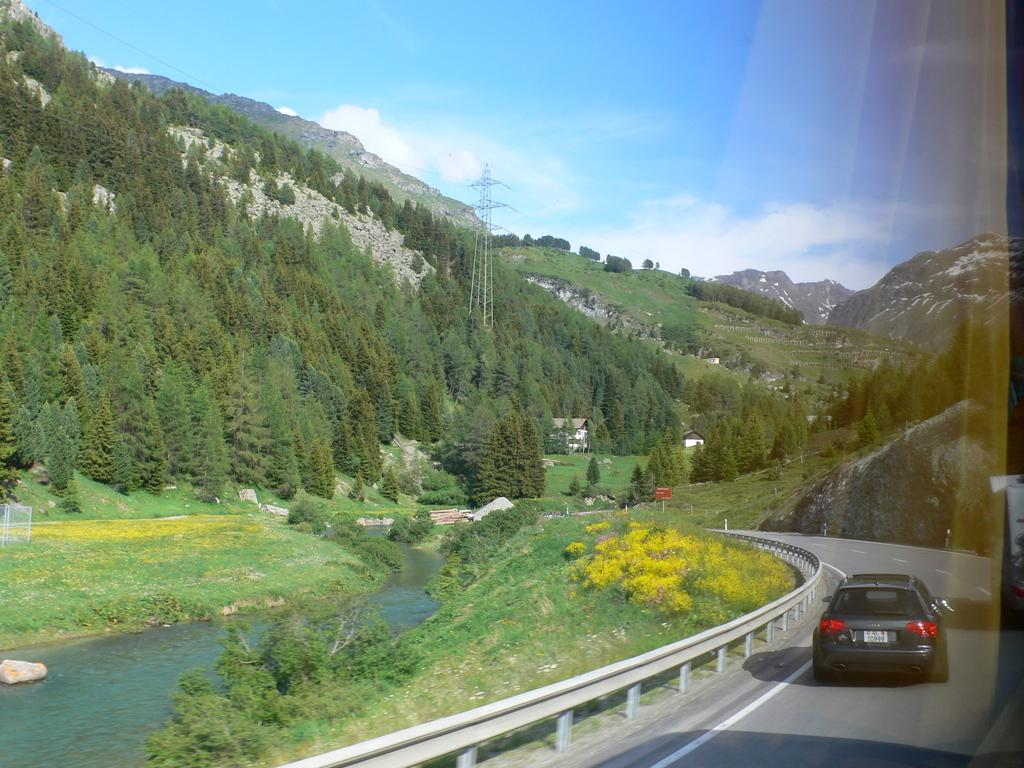What is on the road in the image? There is a vehicle on the road in the image. What type of vegetation can be seen in the image? There is grass, plants, and trees in the image. What can be seen in the water in the image? The facts do not specify what can be seen in the water. What type of structures are present in the image? There are houses, poles, and a cell tower in the image. What else can be seen in the image? There are cables and hills in the image. What is visible in the background of the image? The sky is visible in the background of the image. What is the effect of the park on the value of the houses in the image? There is no park mentioned in the image, so it is not possible to determine the effect of a park on the value of the houses. 